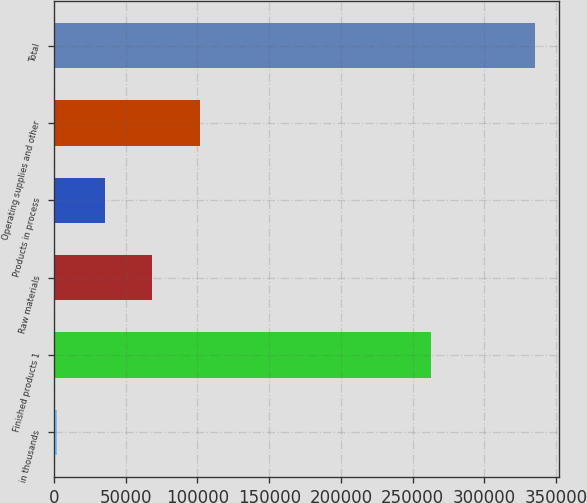<chart> <loc_0><loc_0><loc_500><loc_500><bar_chart><fcel>in thousands<fcel>Finished products 1<fcel>Raw materials<fcel>Products in process<fcel>Operating supplies and other<fcel>Total<nl><fcel>2012<fcel>262886<fcel>68614<fcel>35313<fcel>101915<fcel>335022<nl></chart> 